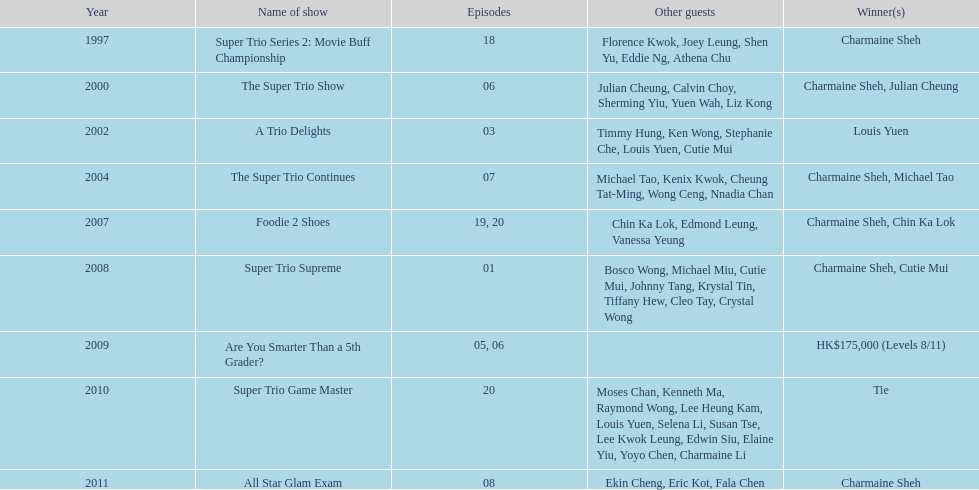In what year did the unique occurrence of a tie transpire? 2010. 